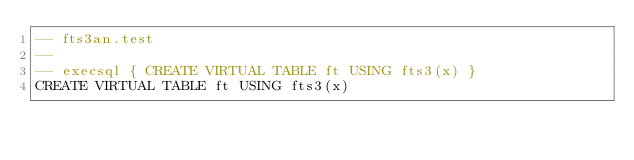<code> <loc_0><loc_0><loc_500><loc_500><_SQL_>-- fts3an.test
-- 
-- execsql { CREATE VIRTUAL TABLE ft USING fts3(x) }
CREATE VIRTUAL TABLE ft USING fts3(x)</code> 